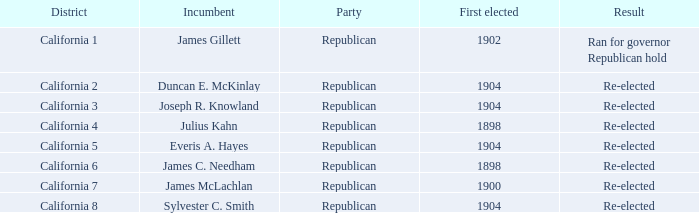Which District has a Result of Re-elected and a First Elected of 1898? California 4, California 6. 